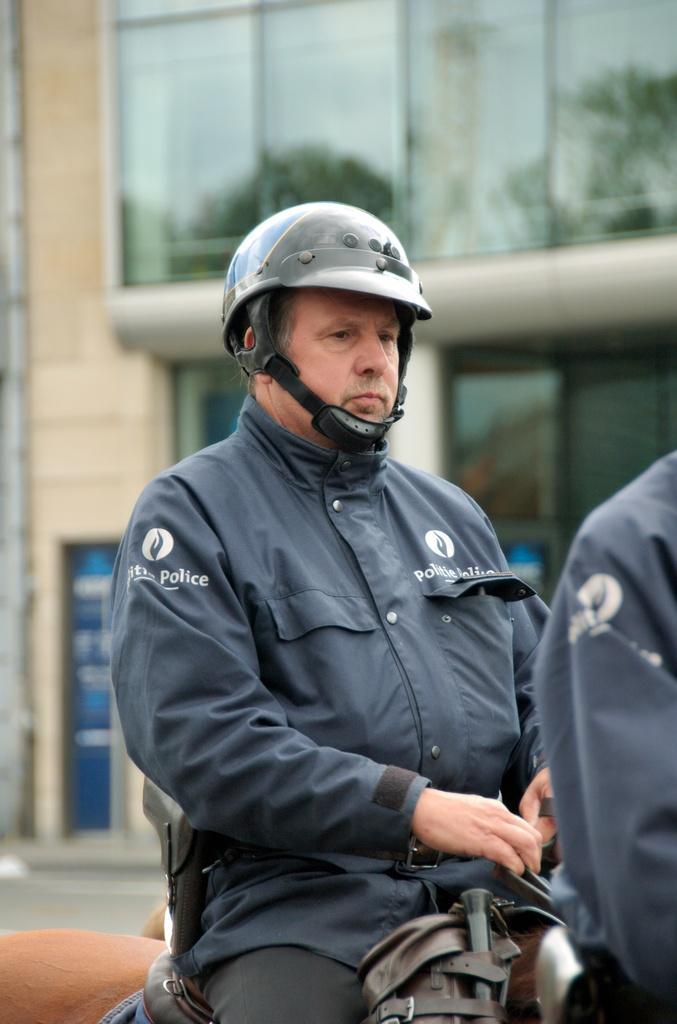Describe this image in one or two sentences. In this image we can see this person wearing a jacket and the helmet is sitting on some animal. The background of the image is slightly blurred, where we can see the glass building. 